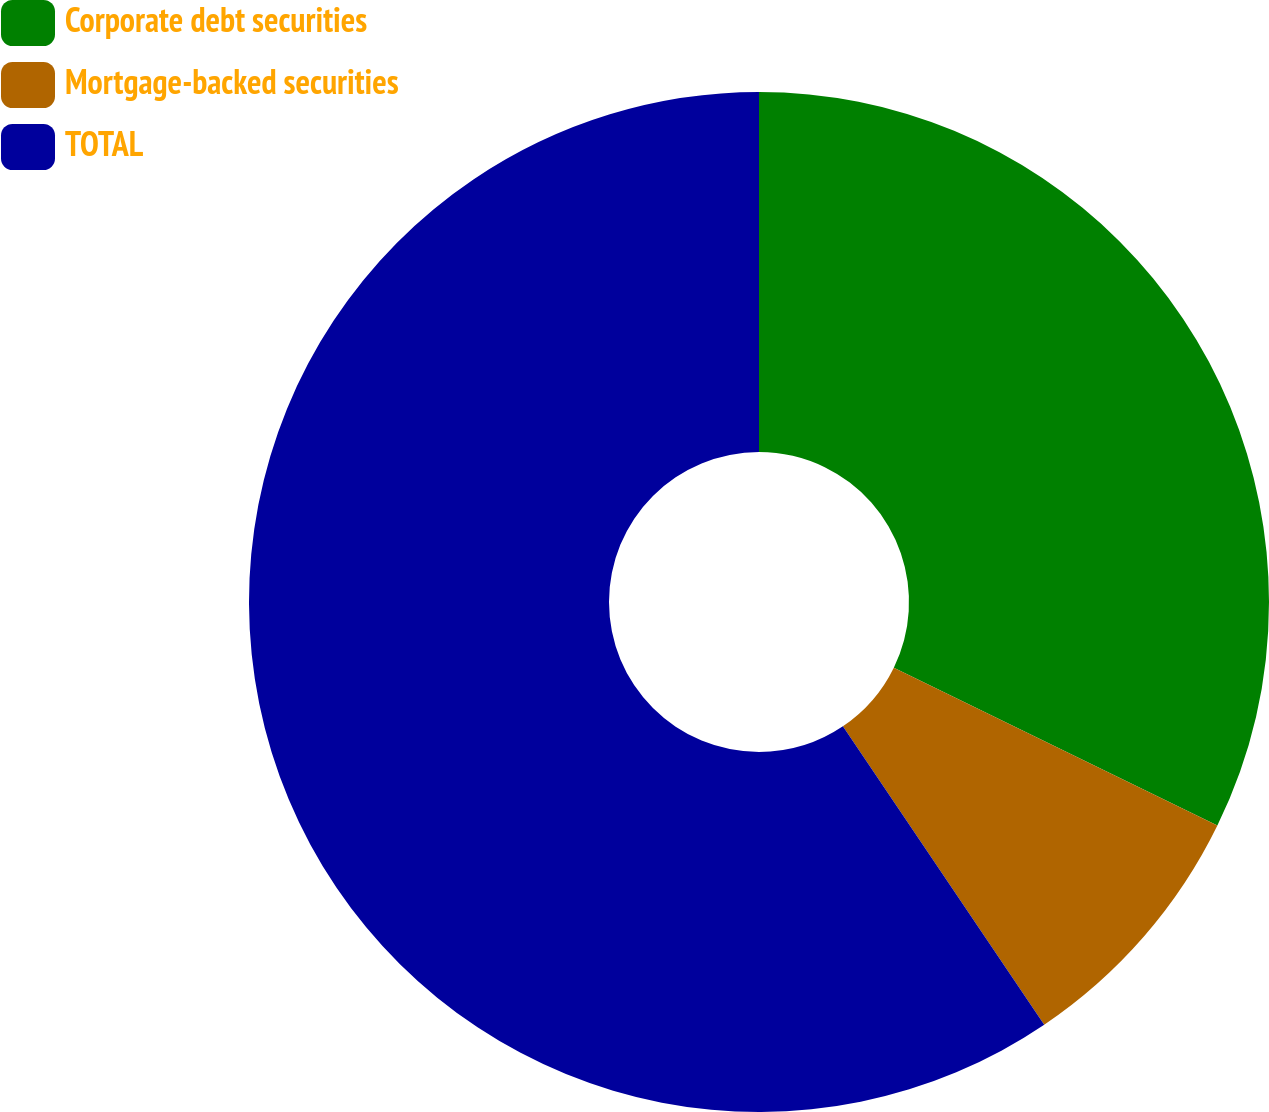Convert chart to OTSL. <chart><loc_0><loc_0><loc_500><loc_500><pie_chart><fcel>Corporate debt securities<fcel>Mortgage-backed securities<fcel>TOTAL<nl><fcel>32.22%<fcel>8.33%<fcel>59.44%<nl></chart> 